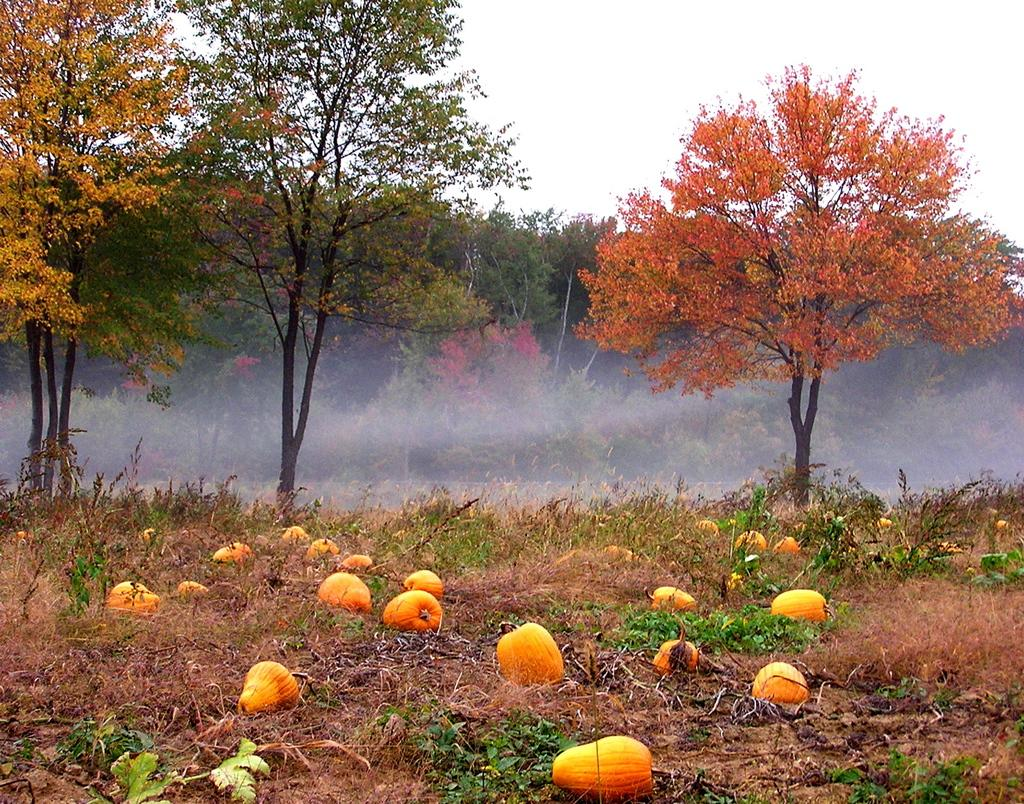What type of surface can be seen in the image? The ground is visible in the image. What type of vegetation is present in the image? There is grass, plants, and trees in the image. What type of fruit or vegetable can be seen in the image? There are pumpkins in the image. What part of the natural environment is visible in the image? The sky is visible in the image. How many feet are visible in the image? There are no feet visible in the image. What type of animal is moving around in the image? There are no animals present in the image, and therefore no movement can be observed. 